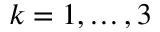Convert formula to latex. <formula><loc_0><loc_0><loc_500><loc_500>k = 1 , \hdots , 3</formula> 